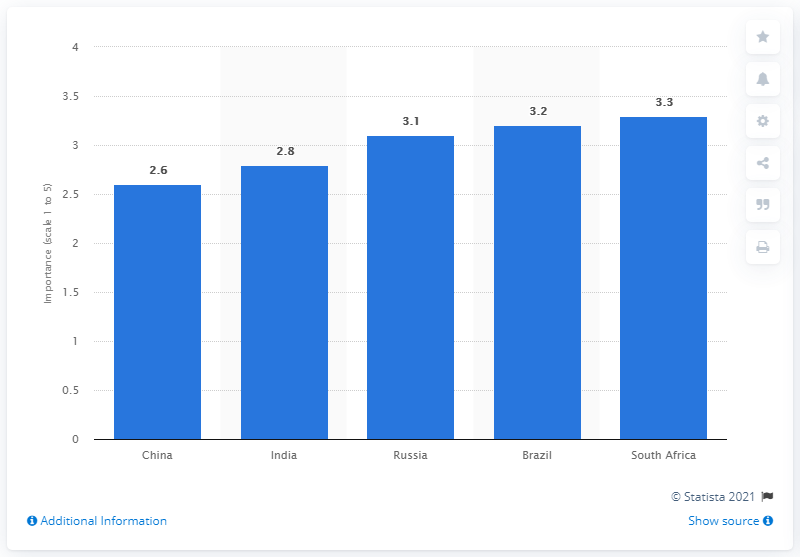Give some essential details in this illustration. The most important market within the BRICS countries is China, which should be the focus of any business looking to succeed in these emerging economies. 